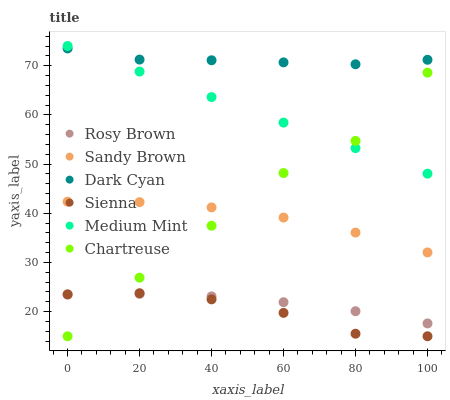Does Sienna have the minimum area under the curve?
Answer yes or no. Yes. Does Dark Cyan have the maximum area under the curve?
Answer yes or no. Yes. Does Rosy Brown have the minimum area under the curve?
Answer yes or no. No. Does Rosy Brown have the maximum area under the curve?
Answer yes or no. No. Is Medium Mint the smoothest?
Answer yes or no. Yes. Is Chartreuse the roughest?
Answer yes or no. Yes. Is Rosy Brown the smoothest?
Answer yes or no. No. Is Rosy Brown the roughest?
Answer yes or no. No. Does Sienna have the lowest value?
Answer yes or no. Yes. Does Rosy Brown have the lowest value?
Answer yes or no. No. Does Medium Mint have the highest value?
Answer yes or no. Yes. Does Sienna have the highest value?
Answer yes or no. No. Is Chartreuse less than Dark Cyan?
Answer yes or no. Yes. Is Dark Cyan greater than Sandy Brown?
Answer yes or no. Yes. Does Chartreuse intersect Sandy Brown?
Answer yes or no. Yes. Is Chartreuse less than Sandy Brown?
Answer yes or no. No. Is Chartreuse greater than Sandy Brown?
Answer yes or no. No. Does Chartreuse intersect Dark Cyan?
Answer yes or no. No. 